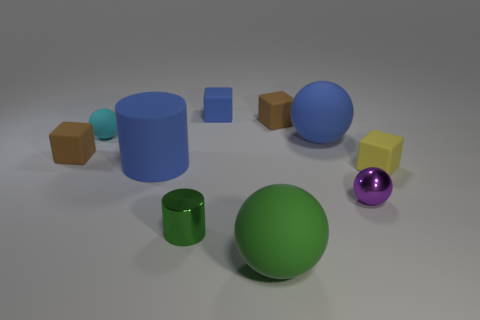How many small yellow rubber objects are the same shape as the tiny blue object?
Offer a terse response. 1. There is a blue matte ball; is it the same size as the rubber thing right of the tiny purple metal ball?
Your response must be concise. No. There is a large rubber thing that is in front of the tiny ball that is in front of the big blue rubber sphere; what shape is it?
Give a very brief answer. Sphere. Is the number of tiny green things to the left of the tiny green metal thing less than the number of rubber balls?
Provide a short and direct response. Yes. There is a big rubber object that is the same color as the rubber cylinder; what shape is it?
Provide a short and direct response. Sphere. What number of red rubber objects have the same size as the green metallic cylinder?
Provide a succinct answer. 0. What shape is the large matte thing that is in front of the purple sphere?
Keep it short and to the point. Sphere. Is the number of yellow spheres less than the number of big blue rubber objects?
Provide a short and direct response. Yes. Are there any other things that have the same color as the small cylinder?
Give a very brief answer. Yes. There is a ball that is in front of the small purple metallic sphere; what is its size?
Provide a short and direct response. Large. 